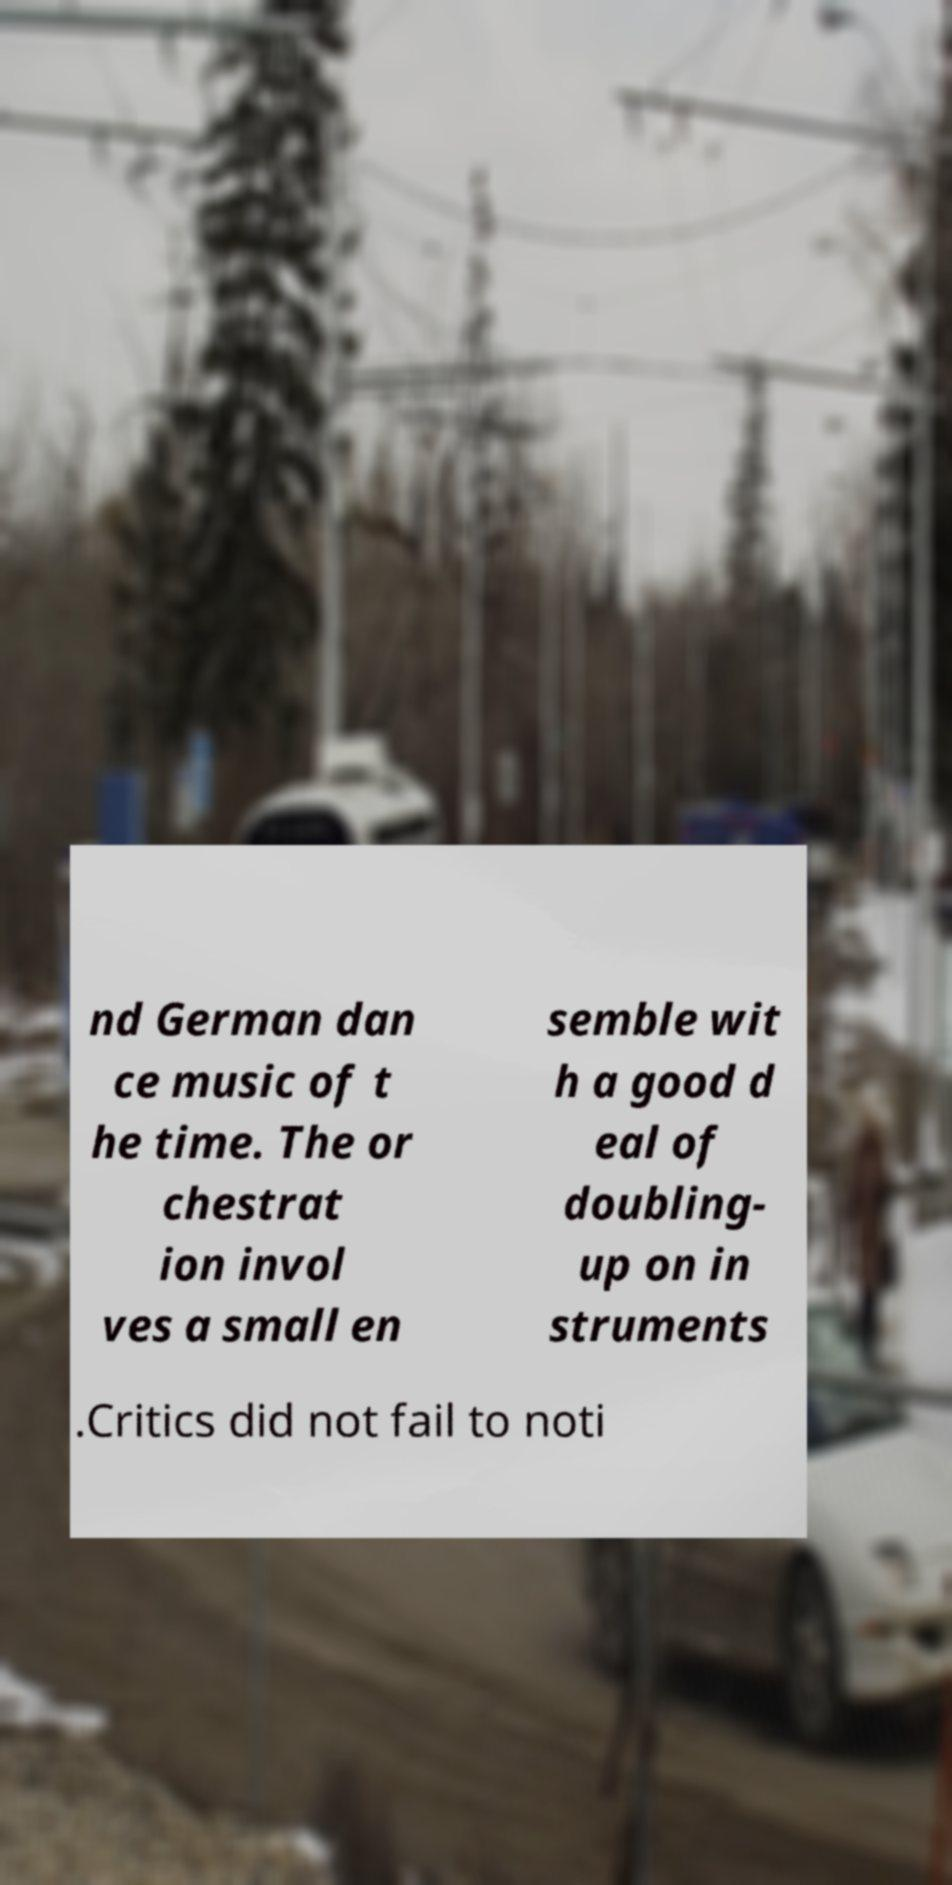For documentation purposes, I need the text within this image transcribed. Could you provide that? nd German dan ce music of t he time. The or chestrat ion invol ves a small en semble wit h a good d eal of doubling- up on in struments .Critics did not fail to noti 